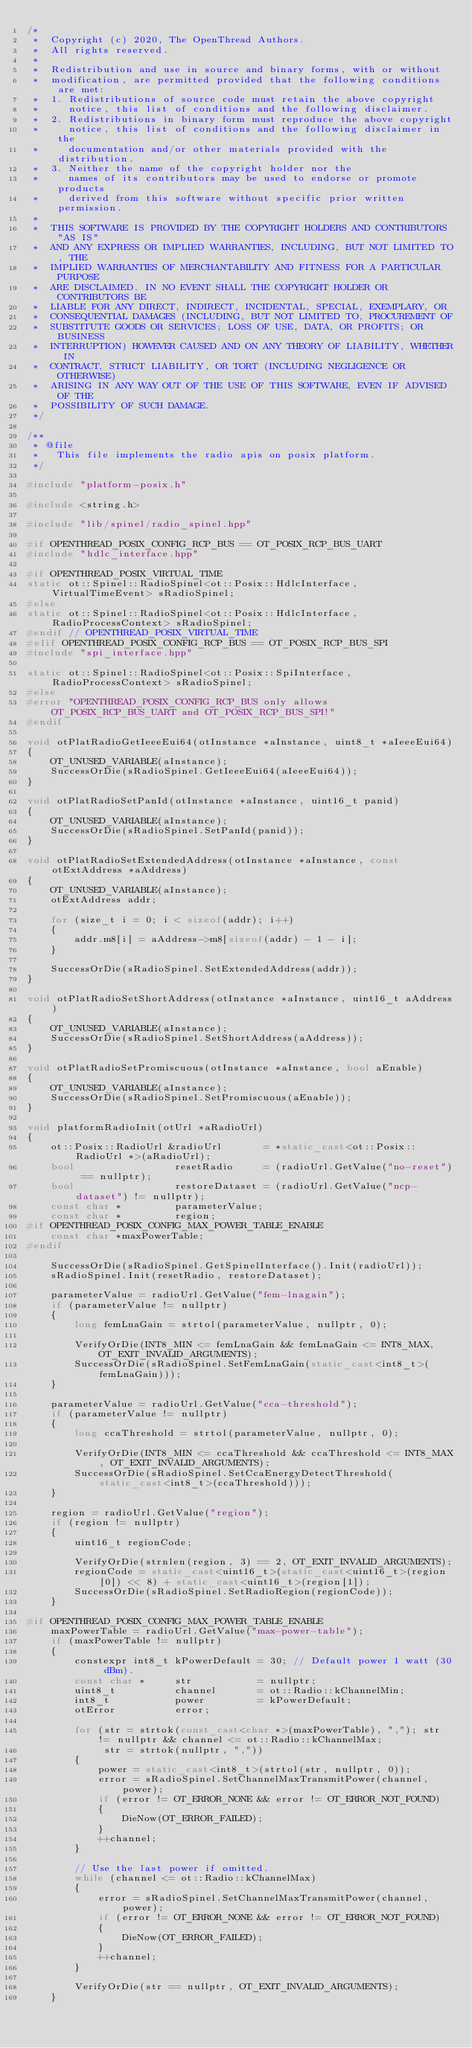Convert code to text. <code><loc_0><loc_0><loc_500><loc_500><_C++_>/*
 *  Copyright (c) 2020, The OpenThread Authors.
 *  All rights reserved.
 *
 *  Redistribution and use in source and binary forms, with or without
 *  modification, are permitted provided that the following conditions are met:
 *  1. Redistributions of source code must retain the above copyright
 *     notice, this list of conditions and the following disclaimer.
 *  2. Redistributions in binary form must reproduce the above copyright
 *     notice, this list of conditions and the following disclaimer in the
 *     documentation and/or other materials provided with the distribution.
 *  3. Neither the name of the copyright holder nor the
 *     names of its contributors may be used to endorse or promote products
 *     derived from this software without specific prior written permission.
 *
 *  THIS SOFTWARE IS PROVIDED BY THE COPYRIGHT HOLDERS AND CONTRIBUTORS "AS IS"
 *  AND ANY EXPRESS OR IMPLIED WARRANTIES, INCLUDING, BUT NOT LIMITED TO, THE
 *  IMPLIED WARRANTIES OF MERCHANTABILITY AND FITNESS FOR A PARTICULAR PURPOSE
 *  ARE DISCLAIMED. IN NO EVENT SHALL THE COPYRIGHT HOLDER OR CONTRIBUTORS BE
 *  LIABLE FOR ANY DIRECT, INDIRECT, INCIDENTAL, SPECIAL, EXEMPLARY, OR
 *  CONSEQUENTIAL DAMAGES (INCLUDING, BUT NOT LIMITED TO, PROCUREMENT OF
 *  SUBSTITUTE GOODS OR SERVICES; LOSS OF USE, DATA, OR PROFITS; OR BUSINESS
 *  INTERRUPTION) HOWEVER CAUSED AND ON ANY THEORY OF LIABILITY, WHETHER IN
 *  CONTRACT, STRICT LIABILITY, OR TORT (INCLUDING NEGLIGENCE OR OTHERWISE)
 *  ARISING IN ANY WAY OUT OF THE USE OF THIS SOFTWARE, EVEN IF ADVISED OF THE
 *  POSSIBILITY OF SUCH DAMAGE.
 */

/**
 * @file
 *   This file implements the radio apis on posix platform.
 */

#include "platform-posix.h"

#include <string.h>

#include "lib/spinel/radio_spinel.hpp"

#if OPENTHREAD_POSIX_CONFIG_RCP_BUS == OT_POSIX_RCP_BUS_UART
#include "hdlc_interface.hpp"

#if OPENTHREAD_POSIX_VIRTUAL_TIME
static ot::Spinel::RadioSpinel<ot::Posix::HdlcInterface, VirtualTimeEvent> sRadioSpinel;
#else
static ot::Spinel::RadioSpinel<ot::Posix::HdlcInterface, RadioProcessContext> sRadioSpinel;
#endif // OPENTHREAD_POSIX_VIRTUAL_TIME
#elif OPENTHREAD_POSIX_CONFIG_RCP_BUS == OT_POSIX_RCP_BUS_SPI
#include "spi_interface.hpp"

static ot::Spinel::RadioSpinel<ot::Posix::SpiInterface, RadioProcessContext> sRadioSpinel;
#else
#error "OPENTHREAD_POSIX_CONFIG_RCP_BUS only allows OT_POSIX_RCP_BUS_UART and OT_POSIX_RCP_BUS_SPI!"
#endif

void otPlatRadioGetIeeeEui64(otInstance *aInstance, uint8_t *aIeeeEui64)
{
    OT_UNUSED_VARIABLE(aInstance);
    SuccessOrDie(sRadioSpinel.GetIeeeEui64(aIeeeEui64));
}

void otPlatRadioSetPanId(otInstance *aInstance, uint16_t panid)
{
    OT_UNUSED_VARIABLE(aInstance);
    SuccessOrDie(sRadioSpinel.SetPanId(panid));
}

void otPlatRadioSetExtendedAddress(otInstance *aInstance, const otExtAddress *aAddress)
{
    OT_UNUSED_VARIABLE(aInstance);
    otExtAddress addr;

    for (size_t i = 0; i < sizeof(addr); i++)
    {
        addr.m8[i] = aAddress->m8[sizeof(addr) - 1 - i];
    }

    SuccessOrDie(sRadioSpinel.SetExtendedAddress(addr));
}

void otPlatRadioSetShortAddress(otInstance *aInstance, uint16_t aAddress)
{
    OT_UNUSED_VARIABLE(aInstance);
    SuccessOrDie(sRadioSpinel.SetShortAddress(aAddress));
}

void otPlatRadioSetPromiscuous(otInstance *aInstance, bool aEnable)
{
    OT_UNUSED_VARIABLE(aInstance);
    SuccessOrDie(sRadioSpinel.SetPromiscuous(aEnable));
}

void platformRadioInit(otUrl *aRadioUrl)
{
    ot::Posix::RadioUrl &radioUrl       = *static_cast<ot::Posix::RadioUrl *>(aRadioUrl);
    bool                 resetRadio     = (radioUrl.GetValue("no-reset") == nullptr);
    bool                 restoreDataset = (radioUrl.GetValue("ncp-dataset") != nullptr);
    const char *         parameterValue;
    const char *         region;
#if OPENTHREAD_POSIX_CONFIG_MAX_POWER_TABLE_ENABLE
    const char *maxPowerTable;
#endif

    SuccessOrDie(sRadioSpinel.GetSpinelInterface().Init(radioUrl));
    sRadioSpinel.Init(resetRadio, restoreDataset);

    parameterValue = radioUrl.GetValue("fem-lnagain");
    if (parameterValue != nullptr)
    {
        long femLnaGain = strtol(parameterValue, nullptr, 0);

        VerifyOrDie(INT8_MIN <= femLnaGain && femLnaGain <= INT8_MAX, OT_EXIT_INVALID_ARGUMENTS);
        SuccessOrDie(sRadioSpinel.SetFemLnaGain(static_cast<int8_t>(femLnaGain)));
    }

    parameterValue = radioUrl.GetValue("cca-threshold");
    if (parameterValue != nullptr)
    {
        long ccaThreshold = strtol(parameterValue, nullptr, 0);

        VerifyOrDie(INT8_MIN <= ccaThreshold && ccaThreshold <= INT8_MAX, OT_EXIT_INVALID_ARGUMENTS);
        SuccessOrDie(sRadioSpinel.SetCcaEnergyDetectThreshold(static_cast<int8_t>(ccaThreshold)));
    }

    region = radioUrl.GetValue("region");
    if (region != nullptr)
    {
        uint16_t regionCode;

        VerifyOrDie(strnlen(region, 3) == 2, OT_EXIT_INVALID_ARGUMENTS);
        regionCode = static_cast<uint16_t>(static_cast<uint16_t>(region[0]) << 8) + static_cast<uint16_t>(region[1]);
        SuccessOrDie(sRadioSpinel.SetRadioRegion(regionCode));
    }

#if OPENTHREAD_POSIX_CONFIG_MAX_POWER_TABLE_ENABLE
    maxPowerTable = radioUrl.GetValue("max-power-table");
    if (maxPowerTable != nullptr)
    {
        constexpr int8_t kPowerDefault = 30; // Default power 1 watt (30 dBm).
        const char *     str           = nullptr;
        uint8_t          channel       = ot::Radio::kChannelMin;
        int8_t           power         = kPowerDefault;
        otError          error;

        for (str = strtok(const_cast<char *>(maxPowerTable), ","); str != nullptr && channel <= ot::Radio::kChannelMax;
             str = strtok(nullptr, ","))
        {
            power = static_cast<int8_t>(strtol(str, nullptr, 0));
            error = sRadioSpinel.SetChannelMaxTransmitPower(channel, power);
            if (error != OT_ERROR_NONE && error != OT_ERROR_NOT_FOUND)
            {
                DieNow(OT_ERROR_FAILED);
            }
            ++channel;
        }

        // Use the last power if omitted.
        while (channel <= ot::Radio::kChannelMax)
        {
            error = sRadioSpinel.SetChannelMaxTransmitPower(channel, power);
            if (error != OT_ERROR_NONE && error != OT_ERROR_NOT_FOUND)
            {
                DieNow(OT_ERROR_FAILED);
            }
            ++channel;
        }

        VerifyOrDie(str == nullptr, OT_EXIT_INVALID_ARGUMENTS);
    }</code> 